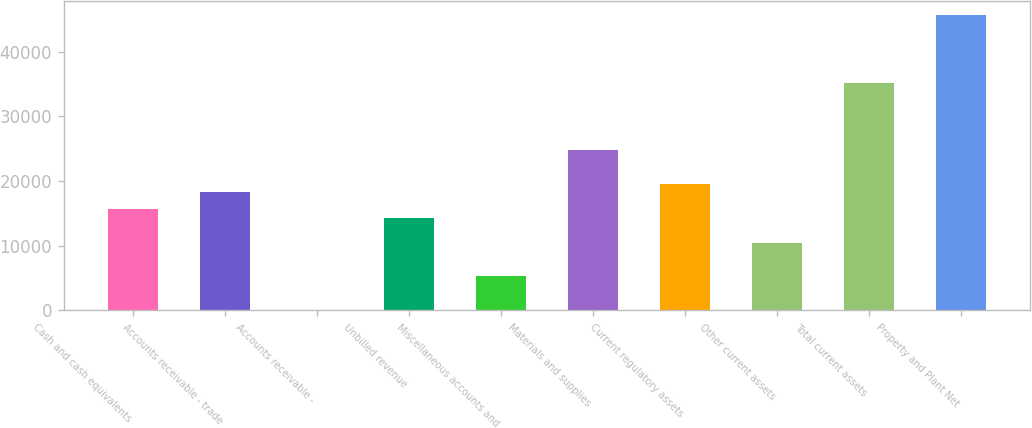Convert chart to OTSL. <chart><loc_0><loc_0><loc_500><loc_500><bar_chart><fcel>Cash and cash equivalents<fcel>Accounts receivable - trade<fcel>Accounts receivable -<fcel>Unbilled revenue<fcel>Miscellaneous accounts and<fcel>Materials and supplies<fcel>Current regulatory assets<fcel>Other current assets<fcel>Total current assets<fcel>Property and Plant Net<nl><fcel>15650.8<fcel>18258.6<fcel>4<fcel>14346.9<fcel>5219.6<fcel>24778.1<fcel>19562.5<fcel>10435.2<fcel>35209.3<fcel>45640.5<nl></chart> 